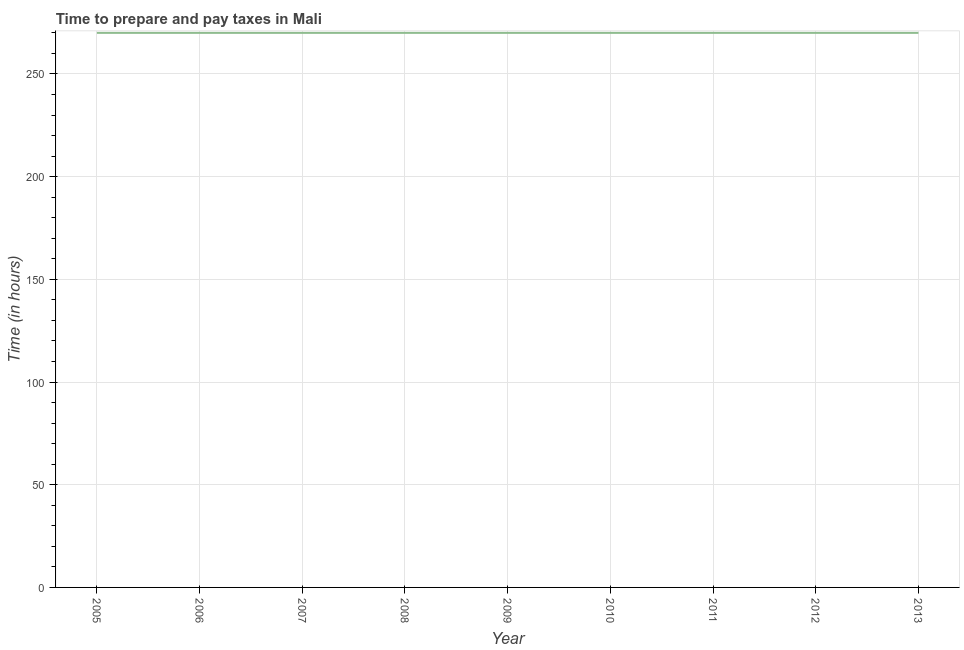What is the time to prepare and pay taxes in 2009?
Offer a very short reply. 270. Across all years, what is the maximum time to prepare and pay taxes?
Your response must be concise. 270. Across all years, what is the minimum time to prepare and pay taxes?
Offer a very short reply. 270. What is the sum of the time to prepare and pay taxes?
Offer a terse response. 2430. What is the average time to prepare and pay taxes per year?
Give a very brief answer. 270. What is the median time to prepare and pay taxes?
Your response must be concise. 270. Do a majority of the years between 2006 and 2011 (inclusive) have time to prepare and pay taxes greater than 50 hours?
Make the answer very short. Yes. Is the time to prepare and pay taxes in 2005 less than that in 2011?
Keep it short and to the point. No. Is the difference between the time to prepare and pay taxes in 2005 and 2009 greater than the difference between any two years?
Give a very brief answer. Yes. What is the difference between the highest and the second highest time to prepare and pay taxes?
Make the answer very short. 0. What is the difference between the highest and the lowest time to prepare and pay taxes?
Your response must be concise. 0. What is the title of the graph?
Offer a very short reply. Time to prepare and pay taxes in Mali. What is the label or title of the Y-axis?
Make the answer very short. Time (in hours). What is the Time (in hours) of 2005?
Provide a succinct answer. 270. What is the Time (in hours) in 2006?
Ensure brevity in your answer.  270. What is the Time (in hours) in 2007?
Offer a terse response. 270. What is the Time (in hours) of 2008?
Your answer should be very brief. 270. What is the Time (in hours) of 2009?
Give a very brief answer. 270. What is the Time (in hours) of 2010?
Offer a very short reply. 270. What is the Time (in hours) in 2011?
Ensure brevity in your answer.  270. What is the Time (in hours) of 2012?
Make the answer very short. 270. What is the Time (in hours) in 2013?
Make the answer very short. 270. What is the difference between the Time (in hours) in 2005 and 2008?
Your answer should be very brief. 0. What is the difference between the Time (in hours) in 2005 and 2009?
Give a very brief answer. 0. What is the difference between the Time (in hours) in 2005 and 2010?
Offer a very short reply. 0. What is the difference between the Time (in hours) in 2005 and 2012?
Your response must be concise. 0. What is the difference between the Time (in hours) in 2006 and 2007?
Keep it short and to the point. 0. What is the difference between the Time (in hours) in 2006 and 2008?
Offer a terse response. 0. What is the difference between the Time (in hours) in 2006 and 2010?
Your answer should be compact. 0. What is the difference between the Time (in hours) in 2006 and 2011?
Your answer should be very brief. 0. What is the difference between the Time (in hours) in 2006 and 2012?
Your response must be concise. 0. What is the difference between the Time (in hours) in 2007 and 2008?
Offer a terse response. 0. What is the difference between the Time (in hours) in 2007 and 2009?
Your response must be concise. 0. What is the difference between the Time (in hours) in 2007 and 2013?
Keep it short and to the point. 0. What is the difference between the Time (in hours) in 2008 and 2009?
Provide a succinct answer. 0. What is the difference between the Time (in hours) in 2008 and 2010?
Your answer should be very brief. 0. What is the difference between the Time (in hours) in 2008 and 2012?
Give a very brief answer. 0. What is the difference between the Time (in hours) in 2009 and 2010?
Provide a short and direct response. 0. What is the difference between the Time (in hours) in 2009 and 2013?
Your response must be concise. 0. What is the difference between the Time (in hours) in 2010 and 2013?
Provide a succinct answer. 0. What is the ratio of the Time (in hours) in 2005 to that in 2008?
Your answer should be very brief. 1. What is the ratio of the Time (in hours) in 2005 to that in 2010?
Give a very brief answer. 1. What is the ratio of the Time (in hours) in 2005 to that in 2011?
Offer a very short reply. 1. What is the ratio of the Time (in hours) in 2006 to that in 2007?
Offer a very short reply. 1. What is the ratio of the Time (in hours) in 2006 to that in 2009?
Offer a terse response. 1. What is the ratio of the Time (in hours) in 2006 to that in 2011?
Give a very brief answer. 1. What is the ratio of the Time (in hours) in 2006 to that in 2012?
Keep it short and to the point. 1. What is the ratio of the Time (in hours) in 2006 to that in 2013?
Your answer should be very brief. 1. What is the ratio of the Time (in hours) in 2007 to that in 2011?
Offer a very short reply. 1. What is the ratio of the Time (in hours) in 2007 to that in 2012?
Keep it short and to the point. 1. What is the ratio of the Time (in hours) in 2008 to that in 2009?
Give a very brief answer. 1. What is the ratio of the Time (in hours) in 2008 to that in 2010?
Offer a very short reply. 1. What is the ratio of the Time (in hours) in 2008 to that in 2011?
Offer a terse response. 1. What is the ratio of the Time (in hours) in 2008 to that in 2013?
Offer a terse response. 1. What is the ratio of the Time (in hours) in 2009 to that in 2010?
Ensure brevity in your answer.  1. What is the ratio of the Time (in hours) in 2010 to that in 2013?
Give a very brief answer. 1. What is the ratio of the Time (in hours) in 2011 to that in 2012?
Provide a succinct answer. 1. 